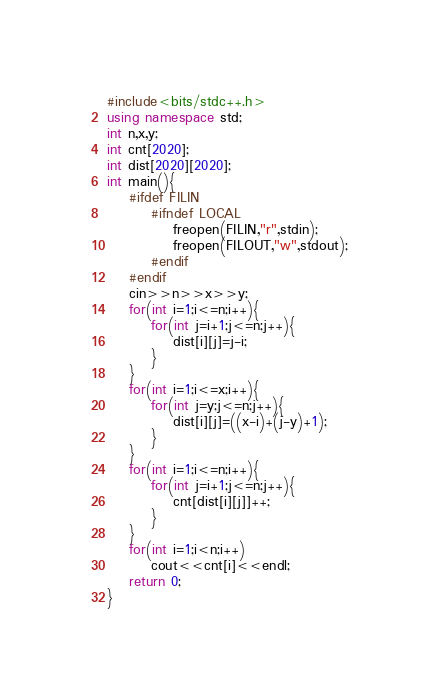Convert code to text. <code><loc_0><loc_0><loc_500><loc_500><_C++_>#include<bits/stdc++.h>
using namespace std;
int n,x,y;
int cnt[2020];
int dist[2020][2020];
int main(){
	#ifdef FILIN
		#ifndef LOCAL
			freopen(FILIN,"r",stdin);
			freopen(FILOUT,"w",stdout);
		#endif
	#endif
	cin>>n>>x>>y;
	for(int i=1;i<=n;i++){
		for(int j=i+1;j<=n;j++){
			dist[i][j]=j-i;
		}
	}
	for(int i=1;i<=x;i++){
		for(int j=y;j<=n;j++){
			dist[i][j]=((x-i)+(j-y)+1);
		} 
	}
	for(int i=1;i<=n;i++){
		for(int j=i+1;j<=n;j++){
			cnt[dist[i][j]]++;
		}
	}
	for(int i=1;i<n;i++)
		cout<<cnt[i]<<endl;
	return 0;
}
</code> 